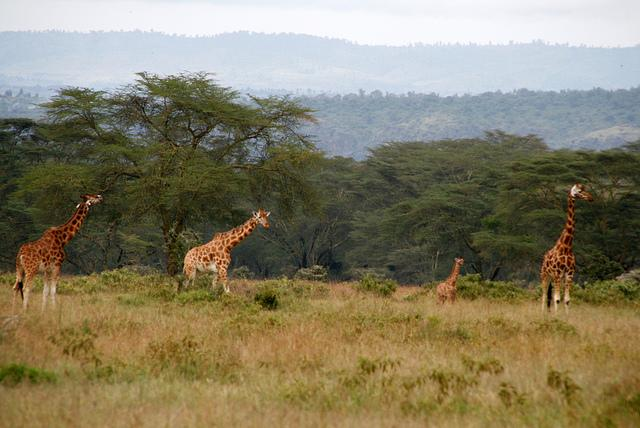What direction are the giraffes looking?

Choices:
A) south
B) east
C) north
D) west east 